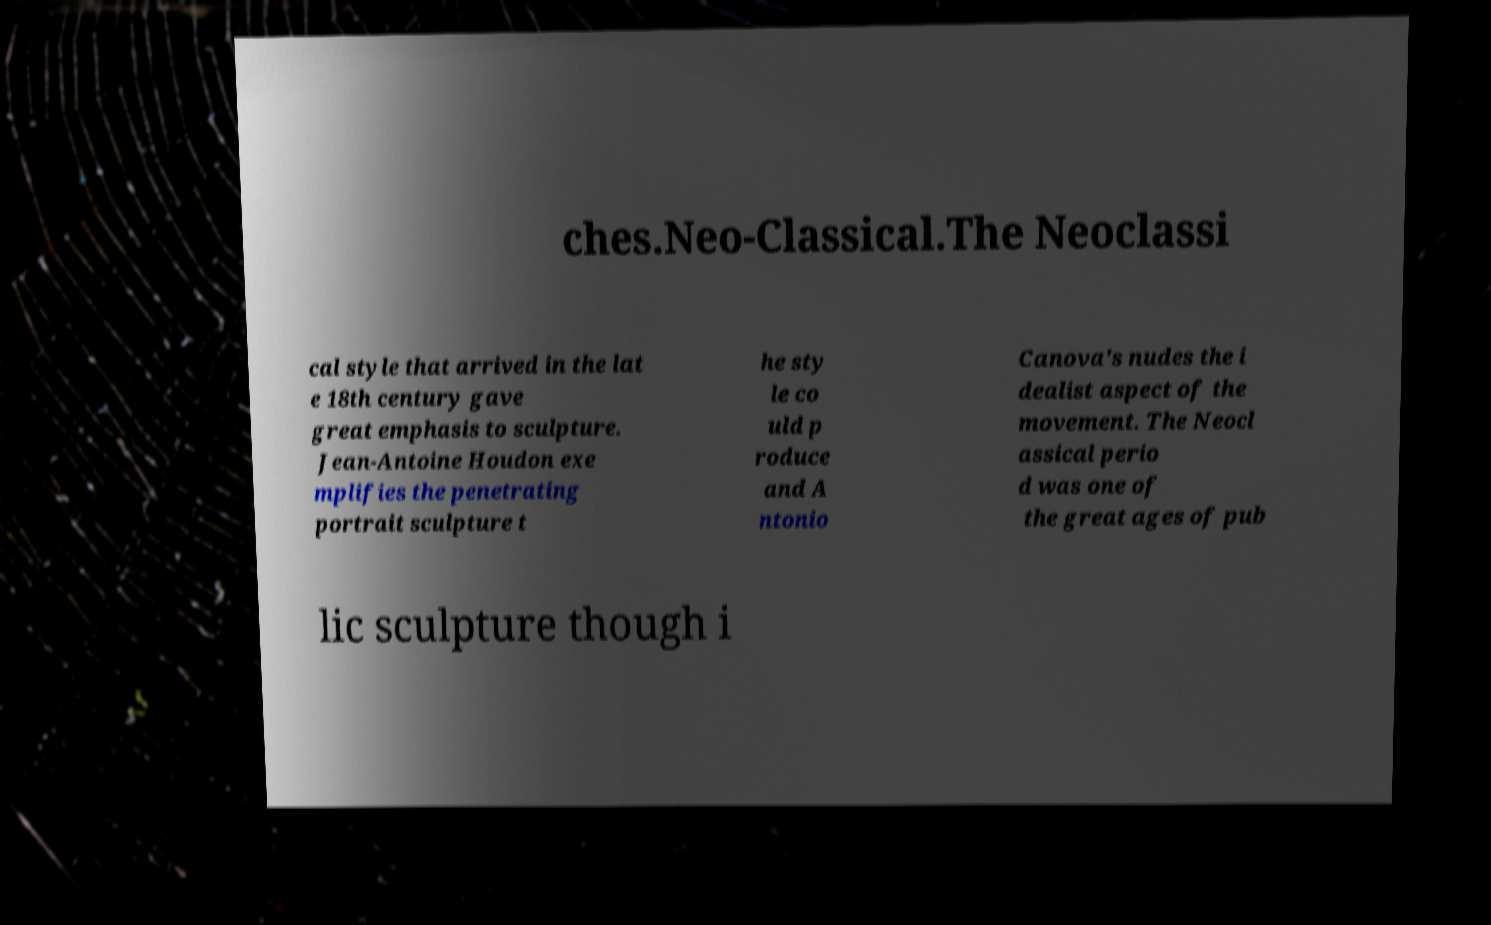Can you accurately transcribe the text from the provided image for me? ches.Neo-Classical.The Neoclassi cal style that arrived in the lat e 18th century gave great emphasis to sculpture. Jean-Antoine Houdon exe mplifies the penetrating portrait sculpture t he sty le co uld p roduce and A ntonio Canova's nudes the i dealist aspect of the movement. The Neocl assical perio d was one of the great ages of pub lic sculpture though i 